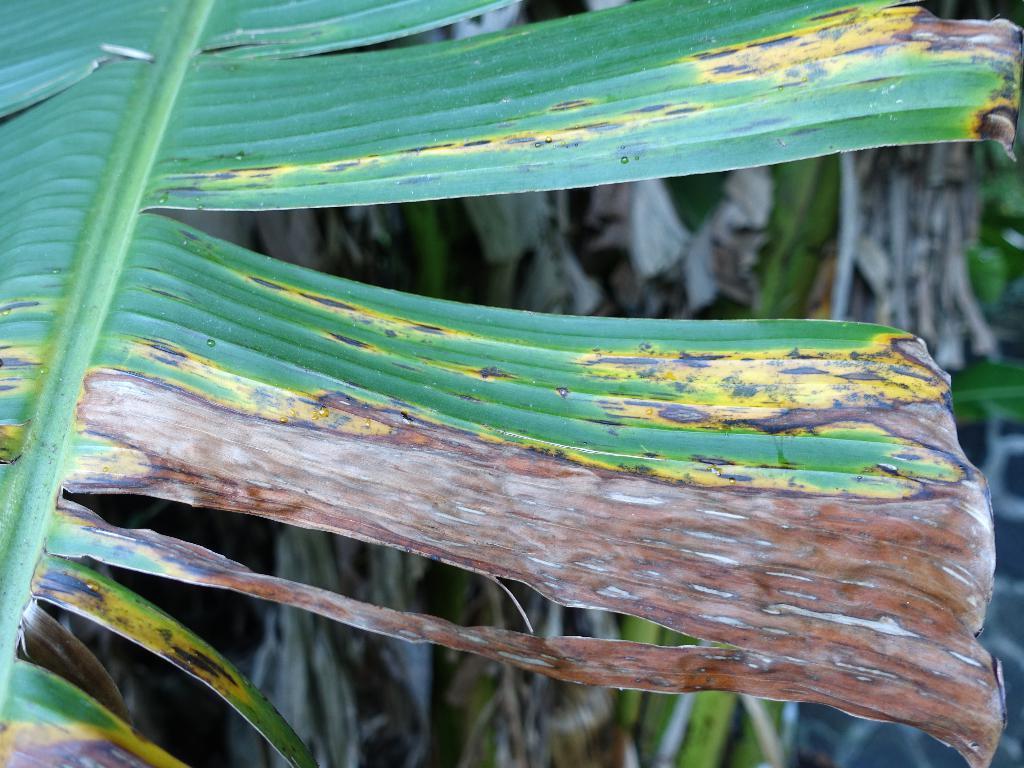Can you describe this image briefly? In this picture, we can see a diseased leaf, and we can see the blurred background with some plants. 